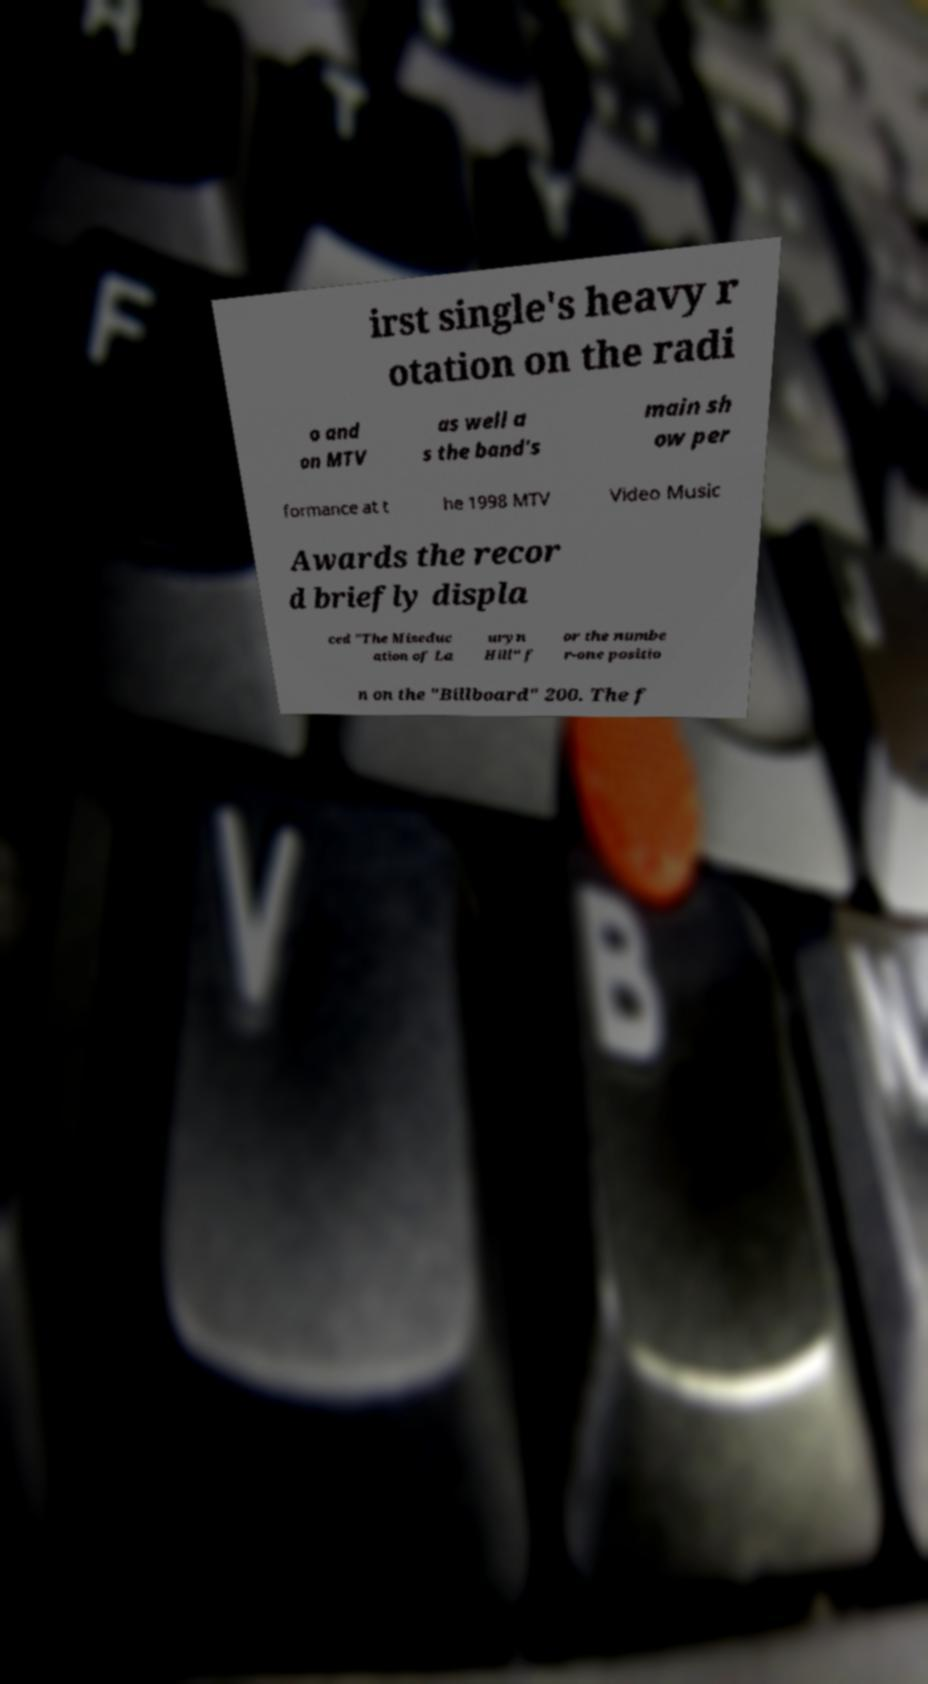There's text embedded in this image that I need extracted. Can you transcribe it verbatim? irst single's heavy r otation on the radi o and on MTV as well a s the band's main sh ow per formance at t he 1998 MTV Video Music Awards the recor d briefly displa ced "The Miseduc ation of La uryn Hill" f or the numbe r-one positio n on the "Billboard" 200. The f 